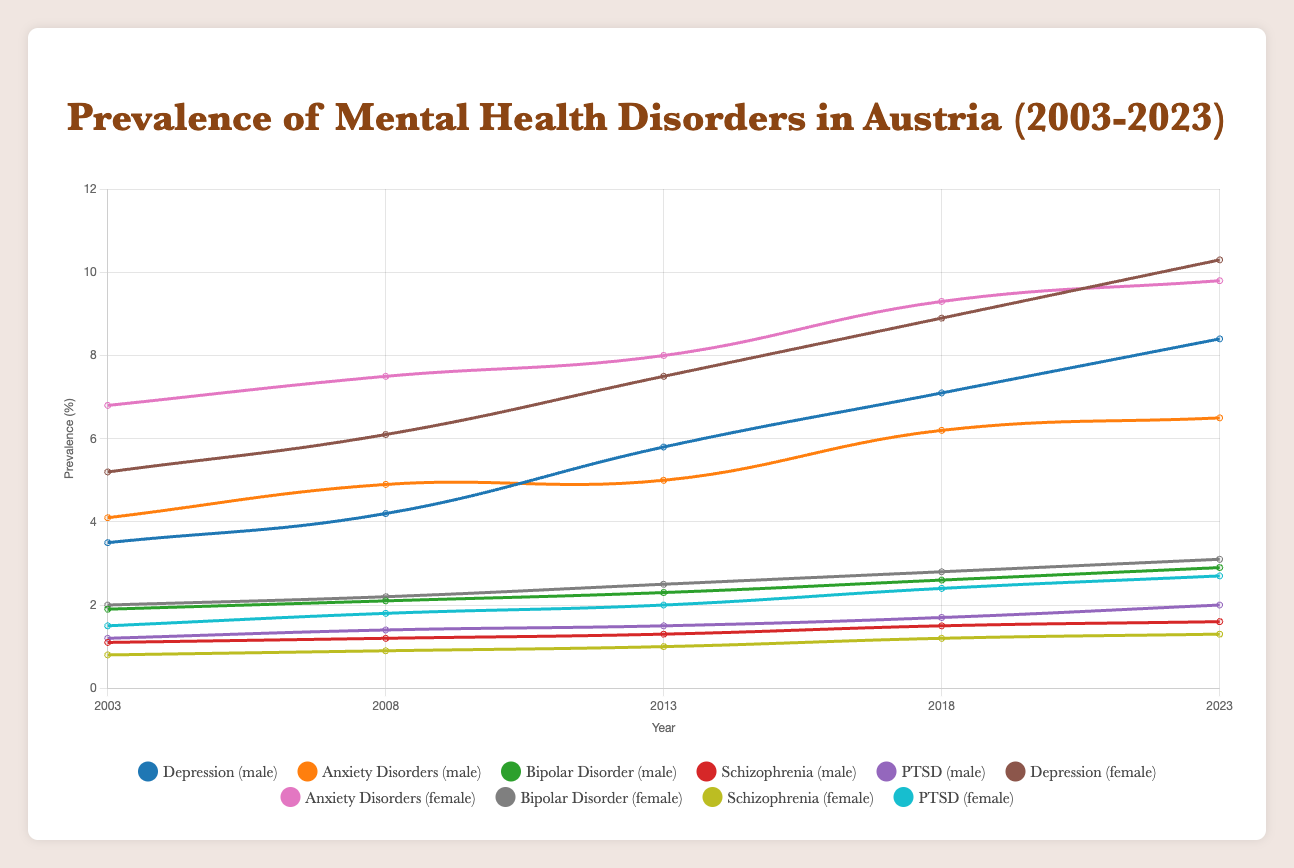Which mental health disorder had the highest prevalence among females in 2023? In the figure, to identify the highest prevalence among females in 2023, you compare the final data points of all disorders for females. Depression has the highest endpoint above all others in 2023.
Answer: Depression How did the prevalence of PTSD among males change from 2003 to 2023? Observe the start and end points of the PTSD line for males. The values increase from 1.2% in 2003 to 2.0% in 2023. Hence, the change is calculated as 2.0% - 1.2%.
Answer: Increased by 0.8% Which gender had a higher prevalence of schizophrenia in 2008? Locate the data points for schizophrenia in 2008 for both males and females. The male data point is at approximately 1.2%, while the female data point is around 0.9%.
Answer: Male What was the combined prevalence of bipolar disorder for both genders in 2013? Find the bipolar disorder data points for males and females in 2013, which are 2.3% and 2.5% respectively. Sum these values: 2.3% + 2.5%.
Answer: 4.8% Which disorder exhibited the greatest increase in prevalence for males from 2003 to 2023? Observe the increase over time for each disorder for males. Calculate the differences for each: Depression (8.4 - 3.5 = 4.9), Anxiety Disorders (6.5 - 4.1 = 2.4), Bipolar Disorder (2.9 - 1.9 = 1.0), Schizophrenia (1.6 - 1.1 = 0.5), PTSD (2.0 - 1.2 = 0.8). Depression has the greatest increase of 4.9%.
Answer: Depression Is the rate of increase for depression higher in males or females from 2003 to 2023? Compare the increase in depression for both genders: Males (8.4 - 3.5 = 4.9) and Females (10.3 - 5.2 = 5.1).
Answer: Females In which year did the prevalence of anxiety disorders among females surpass 9%? Follow the trend line for female anxiety disorders and identify the year it first exceeds 9%, which can be visually confirmed in 2018.
Answer: 2018 What is the trend for schizophrenia in both genders from 2003 to 2023? Look at the lines for schizophrenia for both males and females from start to end. Both display an upward trend from 2003 (1.1% males, 0.8% females) to 2023 (1.6% males, 1.3% females).
Answer: Increasing trend 